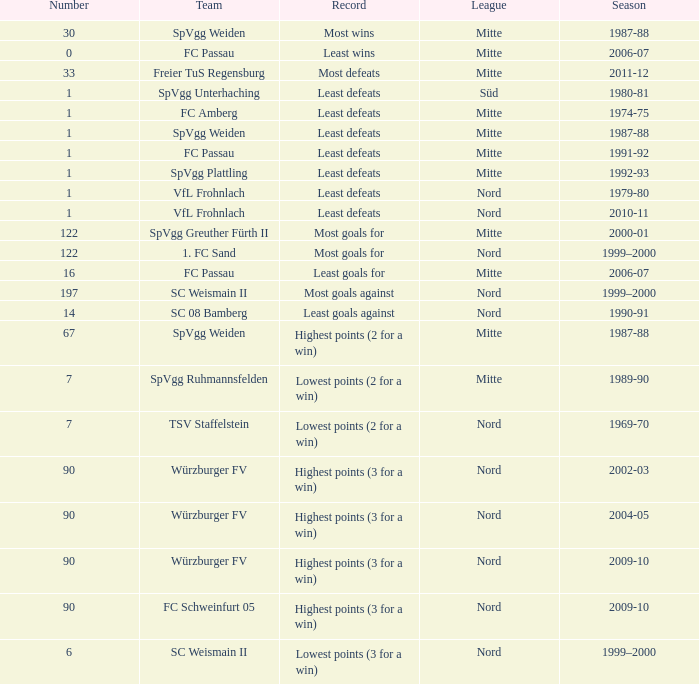What league has a number less than 1? Mitte. I'm looking to parse the entire table for insights. Could you assist me with that? {'header': ['Number', 'Team', 'Record', 'League', 'Season'], 'rows': [['30', 'SpVgg Weiden', 'Most wins', 'Mitte', '1987-88'], ['0', 'FC Passau', 'Least wins', 'Mitte', '2006-07'], ['33', 'Freier TuS Regensburg', 'Most defeats', 'Mitte', '2011-12'], ['1', 'SpVgg Unterhaching', 'Least defeats', 'Süd', '1980-81'], ['1', 'FC Amberg', 'Least defeats', 'Mitte', '1974-75'], ['1', 'SpVgg Weiden', 'Least defeats', 'Mitte', '1987-88'], ['1', 'FC Passau', 'Least defeats', 'Mitte', '1991-92'], ['1', 'SpVgg Plattling', 'Least defeats', 'Mitte', '1992-93'], ['1', 'VfL Frohnlach', 'Least defeats', 'Nord', '1979-80'], ['1', 'VfL Frohnlach', 'Least defeats', 'Nord', '2010-11'], ['122', 'SpVgg Greuther Fürth II', 'Most goals for', 'Mitte', '2000-01'], ['122', '1. FC Sand', 'Most goals for', 'Nord', '1999–2000'], ['16', 'FC Passau', 'Least goals for', 'Mitte', '2006-07'], ['197', 'SC Weismain II', 'Most goals against', 'Nord', '1999–2000'], ['14', 'SC 08 Bamberg', 'Least goals against', 'Nord', '1990-91'], ['67', 'SpVgg Weiden', 'Highest points (2 for a win)', 'Mitte', '1987-88'], ['7', 'SpVgg Ruhmannsfelden', 'Lowest points (2 for a win)', 'Mitte', '1989-90'], ['7', 'TSV Staffelstein', 'Lowest points (2 for a win)', 'Nord', '1969-70'], ['90', 'Würzburger FV', 'Highest points (3 for a win)', 'Nord', '2002-03'], ['90', 'Würzburger FV', 'Highest points (3 for a win)', 'Nord', '2004-05'], ['90', 'Würzburger FV', 'Highest points (3 for a win)', 'Nord', '2009-10'], ['90', 'FC Schweinfurt 05', 'Highest points (3 for a win)', 'Nord', '2009-10'], ['6', 'SC Weismain II', 'Lowest points (3 for a win)', 'Nord', '1999–2000']]} 